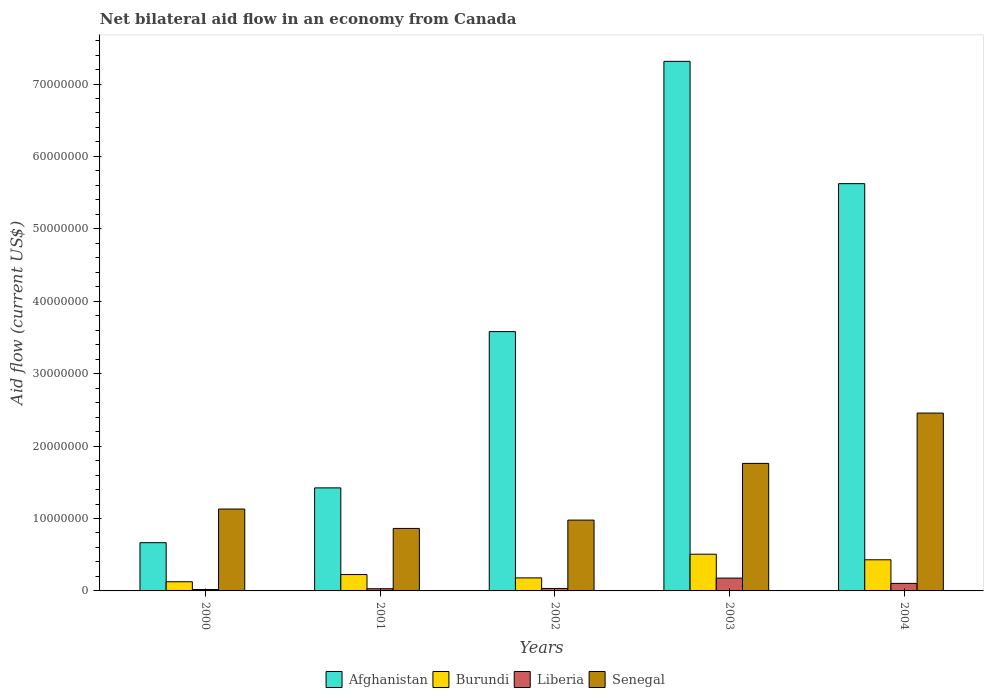How many different coloured bars are there?
Keep it short and to the point. 4. How many groups of bars are there?
Keep it short and to the point. 5. How many bars are there on the 3rd tick from the right?
Ensure brevity in your answer.  4. What is the net bilateral aid flow in Senegal in 2000?
Make the answer very short. 1.13e+07. Across all years, what is the maximum net bilateral aid flow in Liberia?
Your response must be concise. 1.77e+06. Across all years, what is the minimum net bilateral aid flow in Burundi?
Give a very brief answer. 1.27e+06. In which year was the net bilateral aid flow in Burundi maximum?
Give a very brief answer. 2003. In which year was the net bilateral aid flow in Afghanistan minimum?
Give a very brief answer. 2000. What is the total net bilateral aid flow in Liberia in the graph?
Provide a short and direct response. 3.64e+06. What is the difference between the net bilateral aid flow in Liberia in 2002 and that in 2003?
Your response must be concise. -1.43e+06. What is the difference between the net bilateral aid flow in Afghanistan in 2000 and the net bilateral aid flow in Liberia in 2001?
Your answer should be very brief. 6.36e+06. What is the average net bilateral aid flow in Senegal per year?
Your answer should be very brief. 1.44e+07. In the year 2003, what is the difference between the net bilateral aid flow in Senegal and net bilateral aid flow in Burundi?
Provide a short and direct response. 1.25e+07. What is the ratio of the net bilateral aid flow in Afghanistan in 2001 to that in 2003?
Offer a terse response. 0.19. Is the net bilateral aid flow in Senegal in 2000 less than that in 2002?
Your response must be concise. No. Is the difference between the net bilateral aid flow in Senegal in 2002 and 2003 greater than the difference between the net bilateral aid flow in Burundi in 2002 and 2003?
Your answer should be compact. No. What is the difference between the highest and the second highest net bilateral aid flow in Burundi?
Your response must be concise. 7.70e+05. What is the difference between the highest and the lowest net bilateral aid flow in Burundi?
Your answer should be very brief. 3.80e+06. Is the sum of the net bilateral aid flow in Afghanistan in 2002 and 2003 greater than the maximum net bilateral aid flow in Liberia across all years?
Ensure brevity in your answer.  Yes. What does the 1st bar from the left in 2002 represents?
Your answer should be compact. Afghanistan. What does the 4th bar from the right in 2000 represents?
Make the answer very short. Afghanistan. How many bars are there?
Offer a terse response. 20. How many years are there in the graph?
Offer a very short reply. 5. What is the difference between two consecutive major ticks on the Y-axis?
Offer a very short reply. 1.00e+07. Are the values on the major ticks of Y-axis written in scientific E-notation?
Make the answer very short. No. Does the graph contain any zero values?
Keep it short and to the point. No. What is the title of the graph?
Your response must be concise. Net bilateral aid flow in an economy from Canada. What is the label or title of the X-axis?
Give a very brief answer. Years. What is the Aid flow (current US$) of Afghanistan in 2000?
Keep it short and to the point. 6.66e+06. What is the Aid flow (current US$) in Burundi in 2000?
Your answer should be very brief. 1.27e+06. What is the Aid flow (current US$) in Senegal in 2000?
Provide a short and direct response. 1.13e+07. What is the Aid flow (current US$) in Afghanistan in 2001?
Make the answer very short. 1.42e+07. What is the Aid flow (current US$) in Burundi in 2001?
Your answer should be compact. 2.26e+06. What is the Aid flow (current US$) in Senegal in 2001?
Ensure brevity in your answer.  8.63e+06. What is the Aid flow (current US$) in Afghanistan in 2002?
Make the answer very short. 3.58e+07. What is the Aid flow (current US$) in Burundi in 2002?
Give a very brief answer. 1.80e+06. What is the Aid flow (current US$) in Liberia in 2002?
Keep it short and to the point. 3.40e+05. What is the Aid flow (current US$) of Senegal in 2002?
Offer a very short reply. 9.78e+06. What is the Aid flow (current US$) of Afghanistan in 2003?
Provide a succinct answer. 7.31e+07. What is the Aid flow (current US$) in Burundi in 2003?
Offer a very short reply. 5.07e+06. What is the Aid flow (current US$) of Liberia in 2003?
Provide a short and direct response. 1.77e+06. What is the Aid flow (current US$) in Senegal in 2003?
Give a very brief answer. 1.76e+07. What is the Aid flow (current US$) of Afghanistan in 2004?
Your answer should be compact. 5.62e+07. What is the Aid flow (current US$) of Burundi in 2004?
Keep it short and to the point. 4.30e+06. What is the Aid flow (current US$) in Liberia in 2004?
Ensure brevity in your answer.  1.04e+06. What is the Aid flow (current US$) of Senegal in 2004?
Your answer should be compact. 2.46e+07. Across all years, what is the maximum Aid flow (current US$) in Afghanistan?
Your response must be concise. 7.31e+07. Across all years, what is the maximum Aid flow (current US$) of Burundi?
Offer a very short reply. 5.07e+06. Across all years, what is the maximum Aid flow (current US$) in Liberia?
Make the answer very short. 1.77e+06. Across all years, what is the maximum Aid flow (current US$) in Senegal?
Give a very brief answer. 2.46e+07. Across all years, what is the minimum Aid flow (current US$) in Afghanistan?
Make the answer very short. 6.66e+06. Across all years, what is the minimum Aid flow (current US$) of Burundi?
Provide a succinct answer. 1.27e+06. Across all years, what is the minimum Aid flow (current US$) of Senegal?
Give a very brief answer. 8.63e+06. What is the total Aid flow (current US$) of Afghanistan in the graph?
Give a very brief answer. 1.86e+08. What is the total Aid flow (current US$) in Burundi in the graph?
Offer a very short reply. 1.47e+07. What is the total Aid flow (current US$) of Liberia in the graph?
Provide a succinct answer. 3.64e+06. What is the total Aid flow (current US$) in Senegal in the graph?
Make the answer very short. 7.19e+07. What is the difference between the Aid flow (current US$) of Afghanistan in 2000 and that in 2001?
Keep it short and to the point. -7.57e+06. What is the difference between the Aid flow (current US$) of Burundi in 2000 and that in 2001?
Ensure brevity in your answer.  -9.90e+05. What is the difference between the Aid flow (current US$) in Liberia in 2000 and that in 2001?
Give a very brief answer. -1.10e+05. What is the difference between the Aid flow (current US$) in Senegal in 2000 and that in 2001?
Your answer should be very brief. 2.68e+06. What is the difference between the Aid flow (current US$) of Afghanistan in 2000 and that in 2002?
Provide a short and direct response. -2.92e+07. What is the difference between the Aid flow (current US$) of Burundi in 2000 and that in 2002?
Provide a succinct answer. -5.30e+05. What is the difference between the Aid flow (current US$) in Senegal in 2000 and that in 2002?
Give a very brief answer. 1.53e+06. What is the difference between the Aid flow (current US$) of Afghanistan in 2000 and that in 2003?
Offer a very short reply. -6.65e+07. What is the difference between the Aid flow (current US$) of Burundi in 2000 and that in 2003?
Your response must be concise. -3.80e+06. What is the difference between the Aid flow (current US$) of Liberia in 2000 and that in 2003?
Give a very brief answer. -1.58e+06. What is the difference between the Aid flow (current US$) of Senegal in 2000 and that in 2003?
Offer a very short reply. -6.30e+06. What is the difference between the Aid flow (current US$) of Afghanistan in 2000 and that in 2004?
Make the answer very short. -4.96e+07. What is the difference between the Aid flow (current US$) in Burundi in 2000 and that in 2004?
Keep it short and to the point. -3.03e+06. What is the difference between the Aid flow (current US$) in Liberia in 2000 and that in 2004?
Your answer should be very brief. -8.50e+05. What is the difference between the Aid flow (current US$) in Senegal in 2000 and that in 2004?
Keep it short and to the point. -1.32e+07. What is the difference between the Aid flow (current US$) in Afghanistan in 2001 and that in 2002?
Give a very brief answer. -2.16e+07. What is the difference between the Aid flow (current US$) of Burundi in 2001 and that in 2002?
Your response must be concise. 4.60e+05. What is the difference between the Aid flow (current US$) of Liberia in 2001 and that in 2002?
Provide a short and direct response. -4.00e+04. What is the difference between the Aid flow (current US$) of Senegal in 2001 and that in 2002?
Offer a very short reply. -1.15e+06. What is the difference between the Aid flow (current US$) in Afghanistan in 2001 and that in 2003?
Offer a very short reply. -5.89e+07. What is the difference between the Aid flow (current US$) of Burundi in 2001 and that in 2003?
Keep it short and to the point. -2.81e+06. What is the difference between the Aid flow (current US$) of Liberia in 2001 and that in 2003?
Offer a very short reply. -1.47e+06. What is the difference between the Aid flow (current US$) in Senegal in 2001 and that in 2003?
Provide a succinct answer. -8.98e+06. What is the difference between the Aid flow (current US$) in Afghanistan in 2001 and that in 2004?
Your response must be concise. -4.20e+07. What is the difference between the Aid flow (current US$) in Burundi in 2001 and that in 2004?
Give a very brief answer. -2.04e+06. What is the difference between the Aid flow (current US$) of Liberia in 2001 and that in 2004?
Your answer should be very brief. -7.40e+05. What is the difference between the Aid flow (current US$) of Senegal in 2001 and that in 2004?
Provide a short and direct response. -1.59e+07. What is the difference between the Aid flow (current US$) of Afghanistan in 2002 and that in 2003?
Your response must be concise. -3.73e+07. What is the difference between the Aid flow (current US$) in Burundi in 2002 and that in 2003?
Ensure brevity in your answer.  -3.27e+06. What is the difference between the Aid flow (current US$) of Liberia in 2002 and that in 2003?
Keep it short and to the point. -1.43e+06. What is the difference between the Aid flow (current US$) of Senegal in 2002 and that in 2003?
Your response must be concise. -7.83e+06. What is the difference between the Aid flow (current US$) in Afghanistan in 2002 and that in 2004?
Provide a short and direct response. -2.04e+07. What is the difference between the Aid flow (current US$) of Burundi in 2002 and that in 2004?
Your response must be concise. -2.50e+06. What is the difference between the Aid flow (current US$) in Liberia in 2002 and that in 2004?
Your answer should be very brief. -7.00e+05. What is the difference between the Aid flow (current US$) of Senegal in 2002 and that in 2004?
Give a very brief answer. -1.48e+07. What is the difference between the Aid flow (current US$) of Afghanistan in 2003 and that in 2004?
Your response must be concise. 1.69e+07. What is the difference between the Aid flow (current US$) of Burundi in 2003 and that in 2004?
Ensure brevity in your answer.  7.70e+05. What is the difference between the Aid flow (current US$) of Liberia in 2003 and that in 2004?
Offer a very short reply. 7.30e+05. What is the difference between the Aid flow (current US$) in Senegal in 2003 and that in 2004?
Make the answer very short. -6.95e+06. What is the difference between the Aid flow (current US$) of Afghanistan in 2000 and the Aid flow (current US$) of Burundi in 2001?
Your answer should be compact. 4.40e+06. What is the difference between the Aid flow (current US$) in Afghanistan in 2000 and the Aid flow (current US$) in Liberia in 2001?
Your answer should be very brief. 6.36e+06. What is the difference between the Aid flow (current US$) of Afghanistan in 2000 and the Aid flow (current US$) of Senegal in 2001?
Offer a terse response. -1.97e+06. What is the difference between the Aid flow (current US$) of Burundi in 2000 and the Aid flow (current US$) of Liberia in 2001?
Offer a terse response. 9.70e+05. What is the difference between the Aid flow (current US$) of Burundi in 2000 and the Aid flow (current US$) of Senegal in 2001?
Make the answer very short. -7.36e+06. What is the difference between the Aid flow (current US$) of Liberia in 2000 and the Aid flow (current US$) of Senegal in 2001?
Your answer should be very brief. -8.44e+06. What is the difference between the Aid flow (current US$) of Afghanistan in 2000 and the Aid flow (current US$) of Burundi in 2002?
Ensure brevity in your answer.  4.86e+06. What is the difference between the Aid flow (current US$) in Afghanistan in 2000 and the Aid flow (current US$) in Liberia in 2002?
Make the answer very short. 6.32e+06. What is the difference between the Aid flow (current US$) of Afghanistan in 2000 and the Aid flow (current US$) of Senegal in 2002?
Provide a succinct answer. -3.12e+06. What is the difference between the Aid flow (current US$) in Burundi in 2000 and the Aid flow (current US$) in Liberia in 2002?
Ensure brevity in your answer.  9.30e+05. What is the difference between the Aid flow (current US$) of Burundi in 2000 and the Aid flow (current US$) of Senegal in 2002?
Provide a short and direct response. -8.51e+06. What is the difference between the Aid flow (current US$) of Liberia in 2000 and the Aid flow (current US$) of Senegal in 2002?
Keep it short and to the point. -9.59e+06. What is the difference between the Aid flow (current US$) of Afghanistan in 2000 and the Aid flow (current US$) of Burundi in 2003?
Make the answer very short. 1.59e+06. What is the difference between the Aid flow (current US$) of Afghanistan in 2000 and the Aid flow (current US$) of Liberia in 2003?
Offer a terse response. 4.89e+06. What is the difference between the Aid flow (current US$) of Afghanistan in 2000 and the Aid flow (current US$) of Senegal in 2003?
Your answer should be very brief. -1.10e+07. What is the difference between the Aid flow (current US$) in Burundi in 2000 and the Aid flow (current US$) in Liberia in 2003?
Give a very brief answer. -5.00e+05. What is the difference between the Aid flow (current US$) in Burundi in 2000 and the Aid flow (current US$) in Senegal in 2003?
Provide a succinct answer. -1.63e+07. What is the difference between the Aid flow (current US$) of Liberia in 2000 and the Aid flow (current US$) of Senegal in 2003?
Provide a short and direct response. -1.74e+07. What is the difference between the Aid flow (current US$) of Afghanistan in 2000 and the Aid flow (current US$) of Burundi in 2004?
Provide a succinct answer. 2.36e+06. What is the difference between the Aid flow (current US$) in Afghanistan in 2000 and the Aid flow (current US$) in Liberia in 2004?
Ensure brevity in your answer.  5.62e+06. What is the difference between the Aid flow (current US$) in Afghanistan in 2000 and the Aid flow (current US$) in Senegal in 2004?
Make the answer very short. -1.79e+07. What is the difference between the Aid flow (current US$) in Burundi in 2000 and the Aid flow (current US$) in Senegal in 2004?
Keep it short and to the point. -2.33e+07. What is the difference between the Aid flow (current US$) in Liberia in 2000 and the Aid flow (current US$) in Senegal in 2004?
Ensure brevity in your answer.  -2.44e+07. What is the difference between the Aid flow (current US$) of Afghanistan in 2001 and the Aid flow (current US$) of Burundi in 2002?
Make the answer very short. 1.24e+07. What is the difference between the Aid flow (current US$) in Afghanistan in 2001 and the Aid flow (current US$) in Liberia in 2002?
Your answer should be compact. 1.39e+07. What is the difference between the Aid flow (current US$) of Afghanistan in 2001 and the Aid flow (current US$) of Senegal in 2002?
Keep it short and to the point. 4.45e+06. What is the difference between the Aid flow (current US$) of Burundi in 2001 and the Aid flow (current US$) of Liberia in 2002?
Your answer should be very brief. 1.92e+06. What is the difference between the Aid flow (current US$) in Burundi in 2001 and the Aid flow (current US$) in Senegal in 2002?
Provide a succinct answer. -7.52e+06. What is the difference between the Aid flow (current US$) in Liberia in 2001 and the Aid flow (current US$) in Senegal in 2002?
Your response must be concise. -9.48e+06. What is the difference between the Aid flow (current US$) in Afghanistan in 2001 and the Aid flow (current US$) in Burundi in 2003?
Provide a succinct answer. 9.16e+06. What is the difference between the Aid flow (current US$) in Afghanistan in 2001 and the Aid flow (current US$) in Liberia in 2003?
Keep it short and to the point. 1.25e+07. What is the difference between the Aid flow (current US$) in Afghanistan in 2001 and the Aid flow (current US$) in Senegal in 2003?
Offer a very short reply. -3.38e+06. What is the difference between the Aid flow (current US$) in Burundi in 2001 and the Aid flow (current US$) in Senegal in 2003?
Ensure brevity in your answer.  -1.54e+07. What is the difference between the Aid flow (current US$) in Liberia in 2001 and the Aid flow (current US$) in Senegal in 2003?
Your answer should be very brief. -1.73e+07. What is the difference between the Aid flow (current US$) of Afghanistan in 2001 and the Aid flow (current US$) of Burundi in 2004?
Make the answer very short. 9.93e+06. What is the difference between the Aid flow (current US$) of Afghanistan in 2001 and the Aid flow (current US$) of Liberia in 2004?
Ensure brevity in your answer.  1.32e+07. What is the difference between the Aid flow (current US$) in Afghanistan in 2001 and the Aid flow (current US$) in Senegal in 2004?
Your answer should be compact. -1.03e+07. What is the difference between the Aid flow (current US$) in Burundi in 2001 and the Aid flow (current US$) in Liberia in 2004?
Your answer should be very brief. 1.22e+06. What is the difference between the Aid flow (current US$) in Burundi in 2001 and the Aid flow (current US$) in Senegal in 2004?
Make the answer very short. -2.23e+07. What is the difference between the Aid flow (current US$) in Liberia in 2001 and the Aid flow (current US$) in Senegal in 2004?
Offer a terse response. -2.43e+07. What is the difference between the Aid flow (current US$) in Afghanistan in 2002 and the Aid flow (current US$) in Burundi in 2003?
Make the answer very short. 3.07e+07. What is the difference between the Aid flow (current US$) of Afghanistan in 2002 and the Aid flow (current US$) of Liberia in 2003?
Offer a very short reply. 3.40e+07. What is the difference between the Aid flow (current US$) in Afghanistan in 2002 and the Aid flow (current US$) in Senegal in 2003?
Give a very brief answer. 1.82e+07. What is the difference between the Aid flow (current US$) in Burundi in 2002 and the Aid flow (current US$) in Liberia in 2003?
Make the answer very short. 3.00e+04. What is the difference between the Aid flow (current US$) of Burundi in 2002 and the Aid flow (current US$) of Senegal in 2003?
Keep it short and to the point. -1.58e+07. What is the difference between the Aid flow (current US$) in Liberia in 2002 and the Aid flow (current US$) in Senegal in 2003?
Keep it short and to the point. -1.73e+07. What is the difference between the Aid flow (current US$) of Afghanistan in 2002 and the Aid flow (current US$) of Burundi in 2004?
Offer a very short reply. 3.15e+07. What is the difference between the Aid flow (current US$) in Afghanistan in 2002 and the Aid flow (current US$) in Liberia in 2004?
Offer a very short reply. 3.48e+07. What is the difference between the Aid flow (current US$) in Afghanistan in 2002 and the Aid flow (current US$) in Senegal in 2004?
Your response must be concise. 1.12e+07. What is the difference between the Aid flow (current US$) of Burundi in 2002 and the Aid flow (current US$) of Liberia in 2004?
Ensure brevity in your answer.  7.60e+05. What is the difference between the Aid flow (current US$) of Burundi in 2002 and the Aid flow (current US$) of Senegal in 2004?
Your answer should be compact. -2.28e+07. What is the difference between the Aid flow (current US$) in Liberia in 2002 and the Aid flow (current US$) in Senegal in 2004?
Your response must be concise. -2.42e+07. What is the difference between the Aid flow (current US$) in Afghanistan in 2003 and the Aid flow (current US$) in Burundi in 2004?
Ensure brevity in your answer.  6.88e+07. What is the difference between the Aid flow (current US$) of Afghanistan in 2003 and the Aid flow (current US$) of Liberia in 2004?
Your answer should be very brief. 7.21e+07. What is the difference between the Aid flow (current US$) in Afghanistan in 2003 and the Aid flow (current US$) in Senegal in 2004?
Give a very brief answer. 4.86e+07. What is the difference between the Aid flow (current US$) of Burundi in 2003 and the Aid flow (current US$) of Liberia in 2004?
Your answer should be compact. 4.03e+06. What is the difference between the Aid flow (current US$) of Burundi in 2003 and the Aid flow (current US$) of Senegal in 2004?
Make the answer very short. -1.95e+07. What is the difference between the Aid flow (current US$) in Liberia in 2003 and the Aid flow (current US$) in Senegal in 2004?
Give a very brief answer. -2.28e+07. What is the average Aid flow (current US$) in Afghanistan per year?
Give a very brief answer. 3.72e+07. What is the average Aid flow (current US$) in Burundi per year?
Offer a very short reply. 2.94e+06. What is the average Aid flow (current US$) in Liberia per year?
Offer a very short reply. 7.28e+05. What is the average Aid flow (current US$) of Senegal per year?
Give a very brief answer. 1.44e+07. In the year 2000, what is the difference between the Aid flow (current US$) in Afghanistan and Aid flow (current US$) in Burundi?
Keep it short and to the point. 5.39e+06. In the year 2000, what is the difference between the Aid flow (current US$) of Afghanistan and Aid flow (current US$) of Liberia?
Your answer should be compact. 6.47e+06. In the year 2000, what is the difference between the Aid flow (current US$) of Afghanistan and Aid flow (current US$) of Senegal?
Your answer should be very brief. -4.65e+06. In the year 2000, what is the difference between the Aid flow (current US$) in Burundi and Aid flow (current US$) in Liberia?
Offer a very short reply. 1.08e+06. In the year 2000, what is the difference between the Aid flow (current US$) of Burundi and Aid flow (current US$) of Senegal?
Provide a short and direct response. -1.00e+07. In the year 2000, what is the difference between the Aid flow (current US$) in Liberia and Aid flow (current US$) in Senegal?
Provide a succinct answer. -1.11e+07. In the year 2001, what is the difference between the Aid flow (current US$) of Afghanistan and Aid flow (current US$) of Burundi?
Your answer should be compact. 1.20e+07. In the year 2001, what is the difference between the Aid flow (current US$) in Afghanistan and Aid flow (current US$) in Liberia?
Give a very brief answer. 1.39e+07. In the year 2001, what is the difference between the Aid flow (current US$) in Afghanistan and Aid flow (current US$) in Senegal?
Ensure brevity in your answer.  5.60e+06. In the year 2001, what is the difference between the Aid flow (current US$) of Burundi and Aid flow (current US$) of Liberia?
Your response must be concise. 1.96e+06. In the year 2001, what is the difference between the Aid flow (current US$) in Burundi and Aid flow (current US$) in Senegal?
Your response must be concise. -6.37e+06. In the year 2001, what is the difference between the Aid flow (current US$) in Liberia and Aid flow (current US$) in Senegal?
Provide a short and direct response. -8.33e+06. In the year 2002, what is the difference between the Aid flow (current US$) in Afghanistan and Aid flow (current US$) in Burundi?
Your answer should be very brief. 3.40e+07. In the year 2002, what is the difference between the Aid flow (current US$) in Afghanistan and Aid flow (current US$) in Liberia?
Provide a short and direct response. 3.55e+07. In the year 2002, what is the difference between the Aid flow (current US$) in Afghanistan and Aid flow (current US$) in Senegal?
Ensure brevity in your answer.  2.60e+07. In the year 2002, what is the difference between the Aid flow (current US$) of Burundi and Aid flow (current US$) of Liberia?
Offer a terse response. 1.46e+06. In the year 2002, what is the difference between the Aid flow (current US$) of Burundi and Aid flow (current US$) of Senegal?
Your response must be concise. -7.98e+06. In the year 2002, what is the difference between the Aid flow (current US$) in Liberia and Aid flow (current US$) in Senegal?
Your answer should be very brief. -9.44e+06. In the year 2003, what is the difference between the Aid flow (current US$) in Afghanistan and Aid flow (current US$) in Burundi?
Your answer should be compact. 6.81e+07. In the year 2003, what is the difference between the Aid flow (current US$) in Afghanistan and Aid flow (current US$) in Liberia?
Your response must be concise. 7.14e+07. In the year 2003, what is the difference between the Aid flow (current US$) in Afghanistan and Aid flow (current US$) in Senegal?
Make the answer very short. 5.55e+07. In the year 2003, what is the difference between the Aid flow (current US$) of Burundi and Aid flow (current US$) of Liberia?
Provide a short and direct response. 3.30e+06. In the year 2003, what is the difference between the Aid flow (current US$) of Burundi and Aid flow (current US$) of Senegal?
Offer a very short reply. -1.25e+07. In the year 2003, what is the difference between the Aid flow (current US$) of Liberia and Aid flow (current US$) of Senegal?
Make the answer very short. -1.58e+07. In the year 2004, what is the difference between the Aid flow (current US$) of Afghanistan and Aid flow (current US$) of Burundi?
Give a very brief answer. 5.19e+07. In the year 2004, what is the difference between the Aid flow (current US$) in Afghanistan and Aid flow (current US$) in Liberia?
Provide a succinct answer. 5.52e+07. In the year 2004, what is the difference between the Aid flow (current US$) of Afghanistan and Aid flow (current US$) of Senegal?
Give a very brief answer. 3.17e+07. In the year 2004, what is the difference between the Aid flow (current US$) in Burundi and Aid flow (current US$) in Liberia?
Your response must be concise. 3.26e+06. In the year 2004, what is the difference between the Aid flow (current US$) in Burundi and Aid flow (current US$) in Senegal?
Provide a succinct answer. -2.03e+07. In the year 2004, what is the difference between the Aid flow (current US$) in Liberia and Aid flow (current US$) in Senegal?
Offer a very short reply. -2.35e+07. What is the ratio of the Aid flow (current US$) in Afghanistan in 2000 to that in 2001?
Offer a terse response. 0.47. What is the ratio of the Aid flow (current US$) in Burundi in 2000 to that in 2001?
Your answer should be very brief. 0.56. What is the ratio of the Aid flow (current US$) of Liberia in 2000 to that in 2001?
Ensure brevity in your answer.  0.63. What is the ratio of the Aid flow (current US$) in Senegal in 2000 to that in 2001?
Keep it short and to the point. 1.31. What is the ratio of the Aid flow (current US$) in Afghanistan in 2000 to that in 2002?
Your response must be concise. 0.19. What is the ratio of the Aid flow (current US$) of Burundi in 2000 to that in 2002?
Offer a very short reply. 0.71. What is the ratio of the Aid flow (current US$) in Liberia in 2000 to that in 2002?
Give a very brief answer. 0.56. What is the ratio of the Aid flow (current US$) of Senegal in 2000 to that in 2002?
Your response must be concise. 1.16. What is the ratio of the Aid flow (current US$) of Afghanistan in 2000 to that in 2003?
Your answer should be very brief. 0.09. What is the ratio of the Aid flow (current US$) in Burundi in 2000 to that in 2003?
Your answer should be very brief. 0.25. What is the ratio of the Aid flow (current US$) of Liberia in 2000 to that in 2003?
Your response must be concise. 0.11. What is the ratio of the Aid flow (current US$) in Senegal in 2000 to that in 2003?
Ensure brevity in your answer.  0.64. What is the ratio of the Aid flow (current US$) of Afghanistan in 2000 to that in 2004?
Your answer should be compact. 0.12. What is the ratio of the Aid flow (current US$) in Burundi in 2000 to that in 2004?
Your answer should be very brief. 0.3. What is the ratio of the Aid flow (current US$) in Liberia in 2000 to that in 2004?
Your response must be concise. 0.18. What is the ratio of the Aid flow (current US$) in Senegal in 2000 to that in 2004?
Make the answer very short. 0.46. What is the ratio of the Aid flow (current US$) in Afghanistan in 2001 to that in 2002?
Ensure brevity in your answer.  0.4. What is the ratio of the Aid flow (current US$) of Burundi in 2001 to that in 2002?
Your answer should be very brief. 1.26. What is the ratio of the Aid flow (current US$) of Liberia in 2001 to that in 2002?
Your answer should be compact. 0.88. What is the ratio of the Aid flow (current US$) in Senegal in 2001 to that in 2002?
Give a very brief answer. 0.88. What is the ratio of the Aid flow (current US$) in Afghanistan in 2001 to that in 2003?
Provide a short and direct response. 0.19. What is the ratio of the Aid flow (current US$) in Burundi in 2001 to that in 2003?
Offer a terse response. 0.45. What is the ratio of the Aid flow (current US$) of Liberia in 2001 to that in 2003?
Make the answer very short. 0.17. What is the ratio of the Aid flow (current US$) in Senegal in 2001 to that in 2003?
Make the answer very short. 0.49. What is the ratio of the Aid flow (current US$) in Afghanistan in 2001 to that in 2004?
Ensure brevity in your answer.  0.25. What is the ratio of the Aid flow (current US$) of Burundi in 2001 to that in 2004?
Give a very brief answer. 0.53. What is the ratio of the Aid flow (current US$) of Liberia in 2001 to that in 2004?
Keep it short and to the point. 0.29. What is the ratio of the Aid flow (current US$) of Senegal in 2001 to that in 2004?
Your answer should be very brief. 0.35. What is the ratio of the Aid flow (current US$) in Afghanistan in 2002 to that in 2003?
Provide a short and direct response. 0.49. What is the ratio of the Aid flow (current US$) of Burundi in 2002 to that in 2003?
Your answer should be very brief. 0.35. What is the ratio of the Aid flow (current US$) of Liberia in 2002 to that in 2003?
Make the answer very short. 0.19. What is the ratio of the Aid flow (current US$) of Senegal in 2002 to that in 2003?
Your answer should be compact. 0.56. What is the ratio of the Aid flow (current US$) in Afghanistan in 2002 to that in 2004?
Make the answer very short. 0.64. What is the ratio of the Aid flow (current US$) in Burundi in 2002 to that in 2004?
Provide a short and direct response. 0.42. What is the ratio of the Aid flow (current US$) in Liberia in 2002 to that in 2004?
Provide a short and direct response. 0.33. What is the ratio of the Aid flow (current US$) in Senegal in 2002 to that in 2004?
Ensure brevity in your answer.  0.4. What is the ratio of the Aid flow (current US$) in Afghanistan in 2003 to that in 2004?
Give a very brief answer. 1.3. What is the ratio of the Aid flow (current US$) in Burundi in 2003 to that in 2004?
Your answer should be compact. 1.18. What is the ratio of the Aid flow (current US$) of Liberia in 2003 to that in 2004?
Keep it short and to the point. 1.7. What is the ratio of the Aid flow (current US$) in Senegal in 2003 to that in 2004?
Your response must be concise. 0.72. What is the difference between the highest and the second highest Aid flow (current US$) of Afghanistan?
Keep it short and to the point. 1.69e+07. What is the difference between the highest and the second highest Aid flow (current US$) in Burundi?
Provide a succinct answer. 7.70e+05. What is the difference between the highest and the second highest Aid flow (current US$) in Liberia?
Provide a succinct answer. 7.30e+05. What is the difference between the highest and the second highest Aid flow (current US$) in Senegal?
Keep it short and to the point. 6.95e+06. What is the difference between the highest and the lowest Aid flow (current US$) in Afghanistan?
Provide a succinct answer. 6.65e+07. What is the difference between the highest and the lowest Aid flow (current US$) of Burundi?
Give a very brief answer. 3.80e+06. What is the difference between the highest and the lowest Aid flow (current US$) in Liberia?
Your answer should be very brief. 1.58e+06. What is the difference between the highest and the lowest Aid flow (current US$) of Senegal?
Make the answer very short. 1.59e+07. 